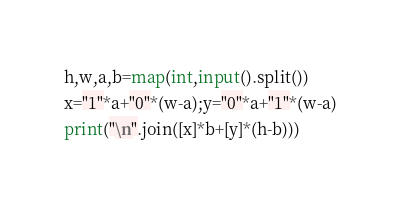<code> <loc_0><loc_0><loc_500><loc_500><_Python_>h,w,a,b=map(int,input().split())
x="1"*a+"0"*(w-a);y="0"*a+"1"*(w-a)
print("\n".join([x]*b+[y]*(h-b)))</code> 